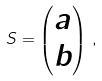<formula> <loc_0><loc_0><loc_500><loc_500>S = \begin{pmatrix} a \\ b \end{pmatrix} \, ,</formula> 